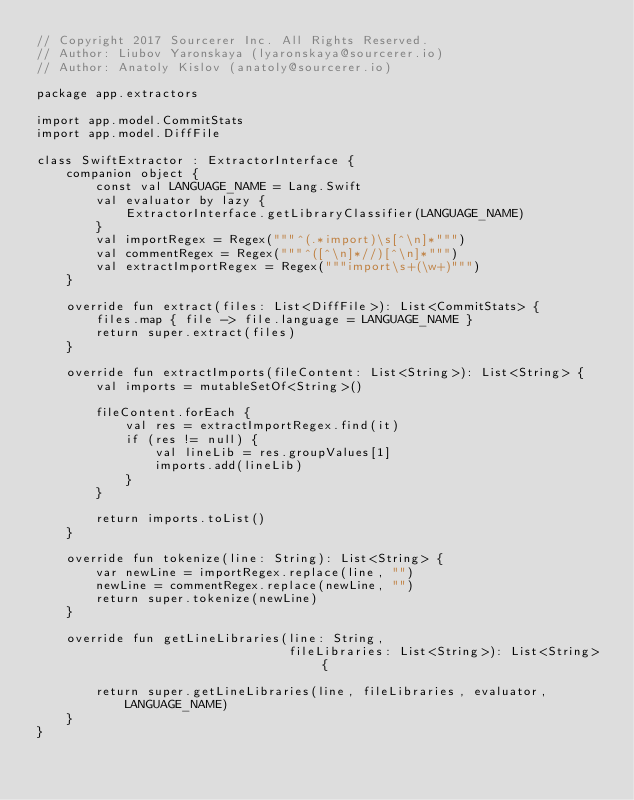Convert code to text. <code><loc_0><loc_0><loc_500><loc_500><_Kotlin_>// Copyright 2017 Sourcerer Inc. All Rights Reserved.
// Author: Liubov Yaronskaya (lyaronskaya@sourcerer.io)
// Author: Anatoly Kislov (anatoly@sourcerer.io)

package app.extractors

import app.model.CommitStats
import app.model.DiffFile

class SwiftExtractor : ExtractorInterface {
    companion object {
        const val LANGUAGE_NAME = Lang.Swift
        val evaluator by lazy {
            ExtractorInterface.getLibraryClassifier(LANGUAGE_NAME)
        }
        val importRegex = Regex("""^(.*import)\s[^\n]*""")
        val commentRegex = Regex("""^([^\n]*//)[^\n]*""")
        val extractImportRegex = Regex("""import\s+(\w+)""")
    }

    override fun extract(files: List<DiffFile>): List<CommitStats> {
        files.map { file -> file.language = LANGUAGE_NAME }
        return super.extract(files)
    }

    override fun extractImports(fileContent: List<String>): List<String> {
        val imports = mutableSetOf<String>()

        fileContent.forEach {
            val res = extractImportRegex.find(it)
            if (res != null) {
                val lineLib = res.groupValues[1]
                imports.add(lineLib)
            }
        }

        return imports.toList()
    }

    override fun tokenize(line: String): List<String> {
        var newLine = importRegex.replace(line, "")
        newLine = commentRegex.replace(newLine, "")
        return super.tokenize(newLine)
    }

    override fun getLineLibraries(line: String,
                                  fileLibraries: List<String>): List<String> {

        return super.getLineLibraries(line, fileLibraries, evaluator,
            LANGUAGE_NAME)
    }
}
</code> 